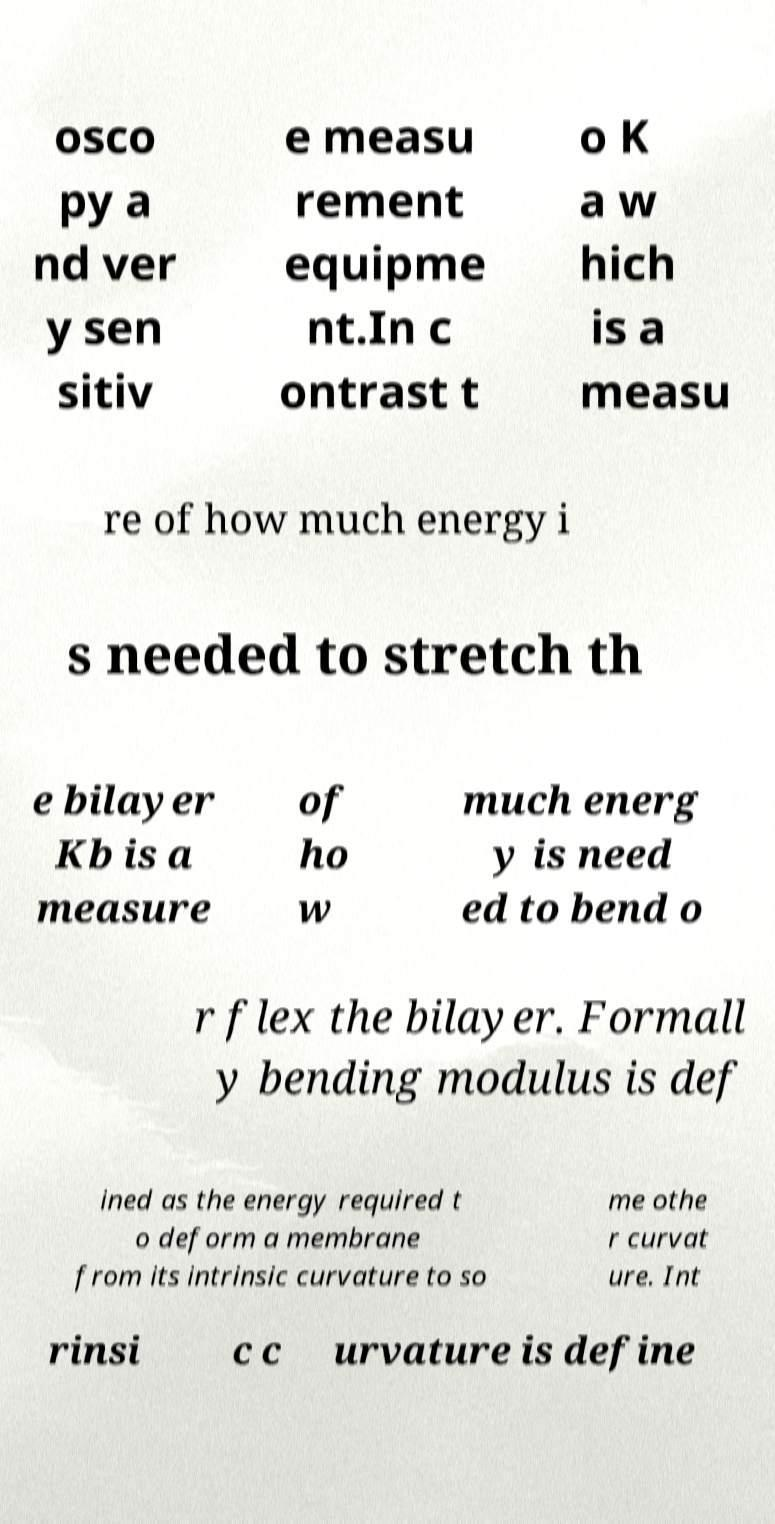Can you read and provide the text displayed in the image?This photo seems to have some interesting text. Can you extract and type it out for me? osco py a nd ver y sen sitiv e measu rement equipme nt.In c ontrast t o K a w hich is a measu re of how much energy i s needed to stretch th e bilayer Kb is a measure of ho w much energ y is need ed to bend o r flex the bilayer. Formall y bending modulus is def ined as the energy required t o deform a membrane from its intrinsic curvature to so me othe r curvat ure. Int rinsi c c urvature is define 